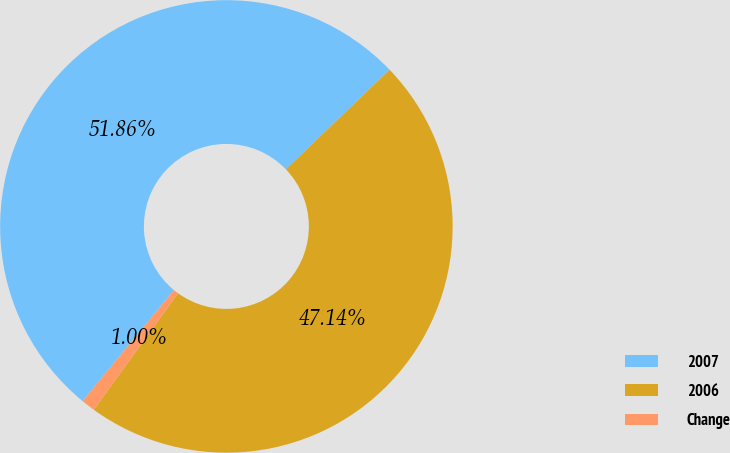<chart> <loc_0><loc_0><loc_500><loc_500><pie_chart><fcel>2007<fcel>2006<fcel>Change<nl><fcel>51.86%<fcel>47.14%<fcel>1.0%<nl></chart> 